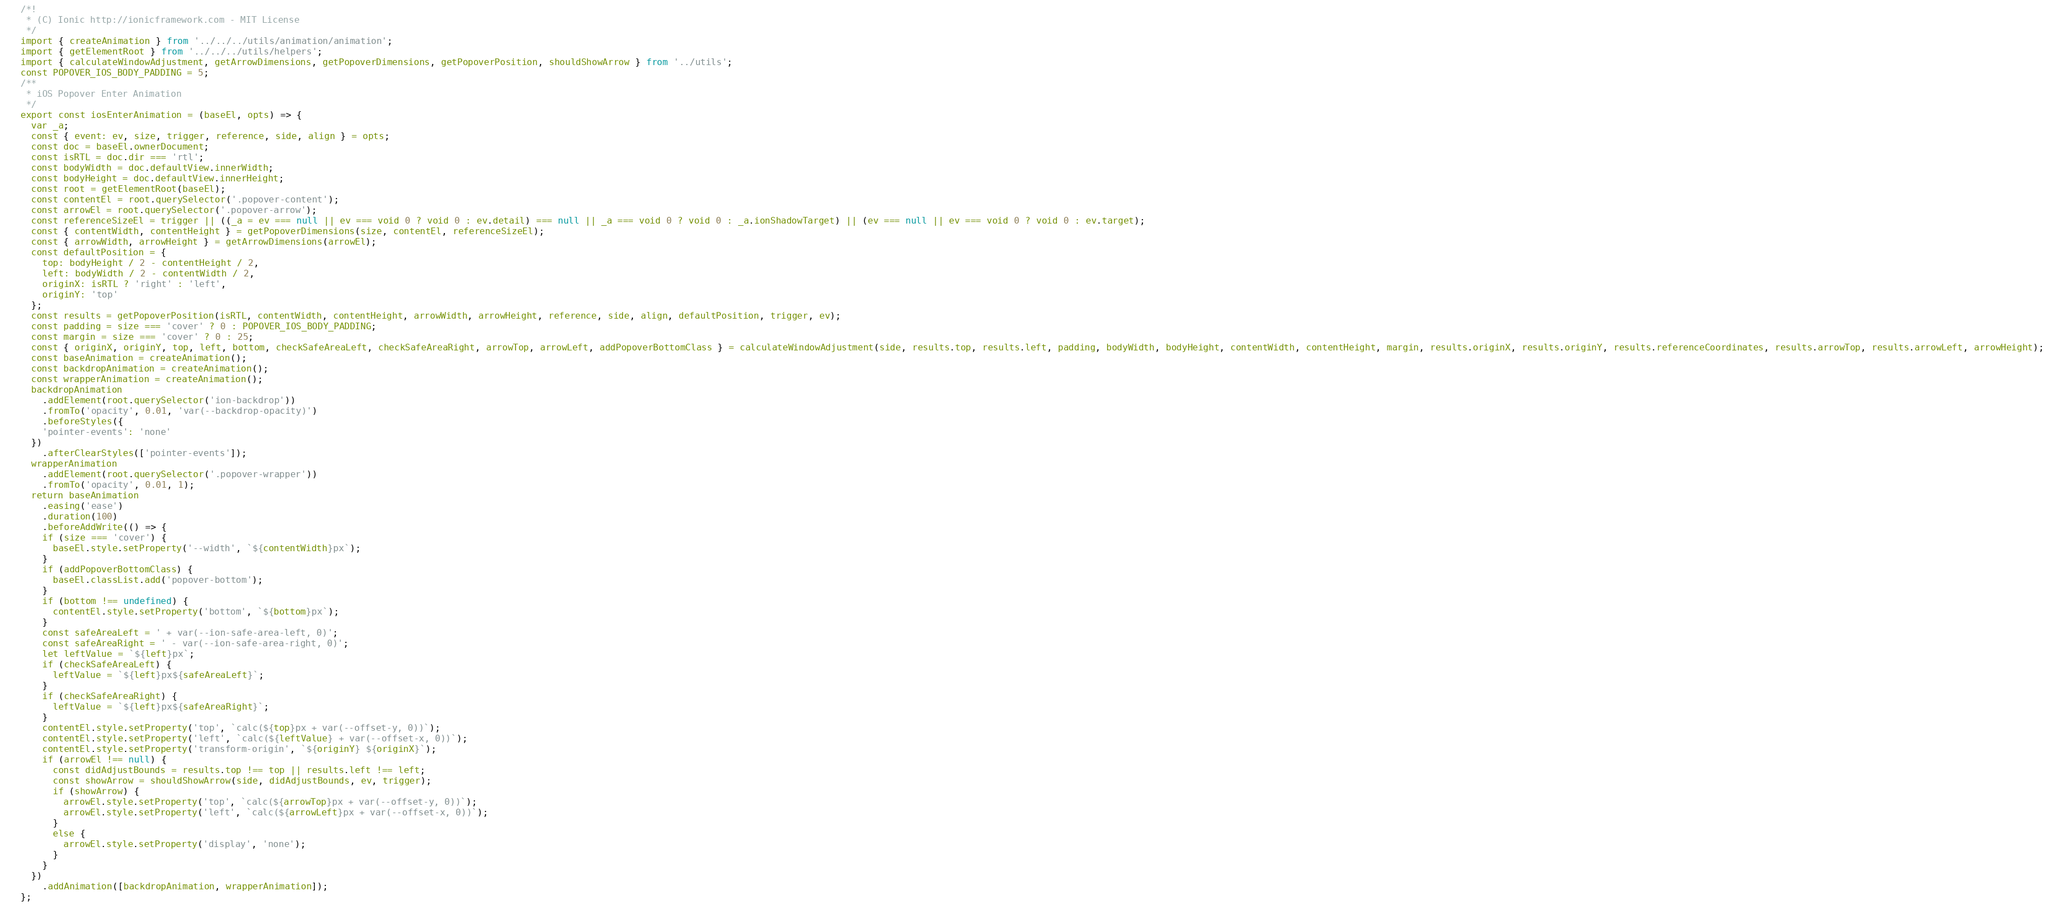<code> <loc_0><loc_0><loc_500><loc_500><_JavaScript_>/*!
 * (C) Ionic http://ionicframework.com - MIT License
 */
import { createAnimation } from '../../../utils/animation/animation';
import { getElementRoot } from '../../../utils/helpers';
import { calculateWindowAdjustment, getArrowDimensions, getPopoverDimensions, getPopoverPosition, shouldShowArrow } from '../utils';
const POPOVER_IOS_BODY_PADDING = 5;
/**
 * iOS Popover Enter Animation
 */
export const iosEnterAnimation = (baseEl, opts) => {
  var _a;
  const { event: ev, size, trigger, reference, side, align } = opts;
  const doc = baseEl.ownerDocument;
  const isRTL = doc.dir === 'rtl';
  const bodyWidth = doc.defaultView.innerWidth;
  const bodyHeight = doc.defaultView.innerHeight;
  const root = getElementRoot(baseEl);
  const contentEl = root.querySelector('.popover-content');
  const arrowEl = root.querySelector('.popover-arrow');
  const referenceSizeEl = trigger || ((_a = ev === null || ev === void 0 ? void 0 : ev.detail) === null || _a === void 0 ? void 0 : _a.ionShadowTarget) || (ev === null || ev === void 0 ? void 0 : ev.target);
  const { contentWidth, contentHeight } = getPopoverDimensions(size, contentEl, referenceSizeEl);
  const { arrowWidth, arrowHeight } = getArrowDimensions(arrowEl);
  const defaultPosition = {
    top: bodyHeight / 2 - contentHeight / 2,
    left: bodyWidth / 2 - contentWidth / 2,
    originX: isRTL ? 'right' : 'left',
    originY: 'top'
  };
  const results = getPopoverPosition(isRTL, contentWidth, contentHeight, arrowWidth, arrowHeight, reference, side, align, defaultPosition, trigger, ev);
  const padding = size === 'cover' ? 0 : POPOVER_IOS_BODY_PADDING;
  const margin = size === 'cover' ? 0 : 25;
  const { originX, originY, top, left, bottom, checkSafeAreaLeft, checkSafeAreaRight, arrowTop, arrowLeft, addPopoverBottomClass } = calculateWindowAdjustment(side, results.top, results.left, padding, bodyWidth, bodyHeight, contentWidth, contentHeight, margin, results.originX, results.originY, results.referenceCoordinates, results.arrowTop, results.arrowLeft, arrowHeight);
  const baseAnimation = createAnimation();
  const backdropAnimation = createAnimation();
  const wrapperAnimation = createAnimation();
  backdropAnimation
    .addElement(root.querySelector('ion-backdrop'))
    .fromTo('opacity', 0.01, 'var(--backdrop-opacity)')
    .beforeStyles({
    'pointer-events': 'none'
  })
    .afterClearStyles(['pointer-events']);
  wrapperAnimation
    .addElement(root.querySelector('.popover-wrapper'))
    .fromTo('opacity', 0.01, 1);
  return baseAnimation
    .easing('ease')
    .duration(100)
    .beforeAddWrite(() => {
    if (size === 'cover') {
      baseEl.style.setProperty('--width', `${contentWidth}px`);
    }
    if (addPopoverBottomClass) {
      baseEl.classList.add('popover-bottom');
    }
    if (bottom !== undefined) {
      contentEl.style.setProperty('bottom', `${bottom}px`);
    }
    const safeAreaLeft = ' + var(--ion-safe-area-left, 0)';
    const safeAreaRight = ' - var(--ion-safe-area-right, 0)';
    let leftValue = `${left}px`;
    if (checkSafeAreaLeft) {
      leftValue = `${left}px${safeAreaLeft}`;
    }
    if (checkSafeAreaRight) {
      leftValue = `${left}px${safeAreaRight}`;
    }
    contentEl.style.setProperty('top', `calc(${top}px + var(--offset-y, 0))`);
    contentEl.style.setProperty('left', `calc(${leftValue} + var(--offset-x, 0))`);
    contentEl.style.setProperty('transform-origin', `${originY} ${originX}`);
    if (arrowEl !== null) {
      const didAdjustBounds = results.top !== top || results.left !== left;
      const showArrow = shouldShowArrow(side, didAdjustBounds, ev, trigger);
      if (showArrow) {
        arrowEl.style.setProperty('top', `calc(${arrowTop}px + var(--offset-y, 0))`);
        arrowEl.style.setProperty('left', `calc(${arrowLeft}px + var(--offset-x, 0))`);
      }
      else {
        arrowEl.style.setProperty('display', 'none');
      }
    }
  })
    .addAnimation([backdropAnimation, wrapperAnimation]);
};
</code> 